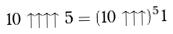<formula> <loc_0><loc_0><loc_500><loc_500>1 0 \uparrow \uparrow \uparrow \uparrow 5 = ( 1 0 \uparrow \uparrow \uparrow ) ^ { 5 } 1</formula> 